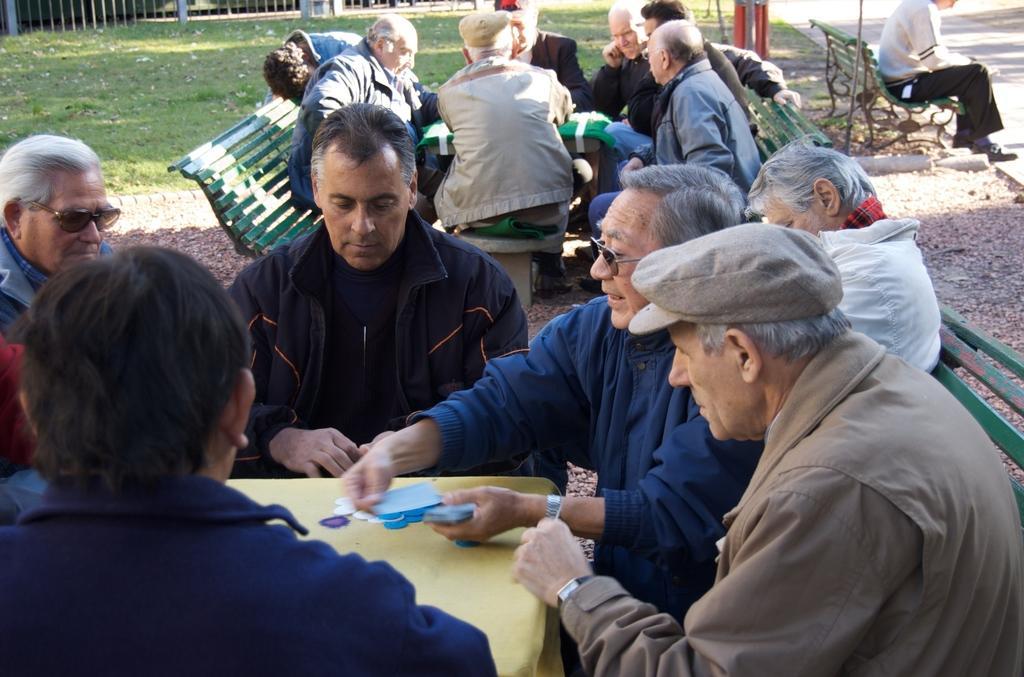In one or two sentences, can you explain what this image depicts? In this image there are group of men who are sitting around the table and playing the cards. The man in the middle is distributing the cards. In the background there are another group of men who are sitting around the table and playing. In the background there is a ground. On the right side there is a bench on which there is a man. 